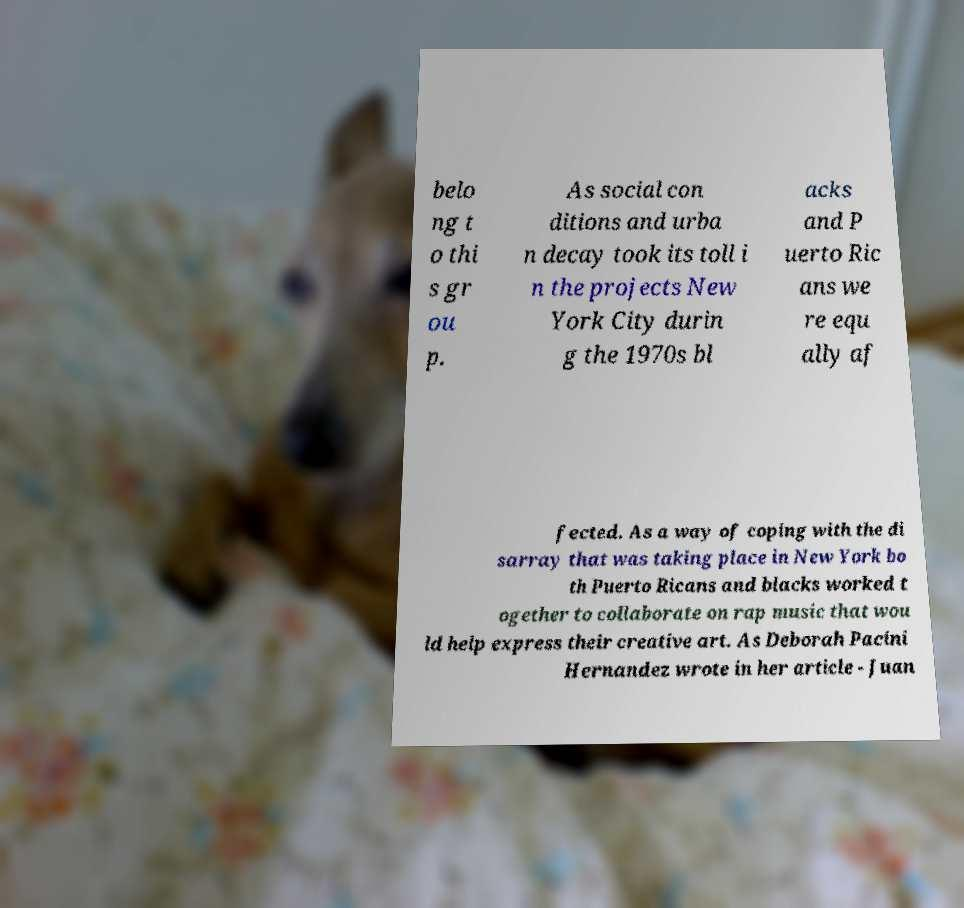Can you read and provide the text displayed in the image?This photo seems to have some interesting text. Can you extract and type it out for me? belo ng t o thi s gr ou p. As social con ditions and urba n decay took its toll i n the projects New York City durin g the 1970s bl acks and P uerto Ric ans we re equ ally af fected. As a way of coping with the di sarray that was taking place in New York bo th Puerto Ricans and blacks worked t ogether to collaborate on rap music that wou ld help express their creative art. As Deborah Pacini Hernandez wrote in her article - Juan 